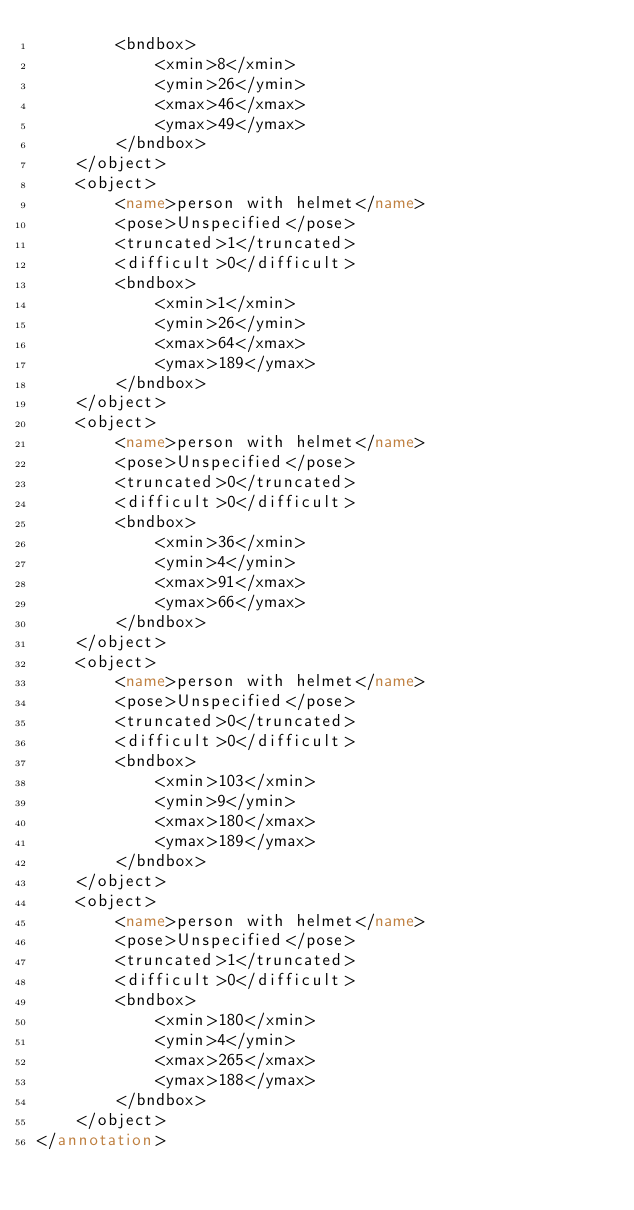Convert code to text. <code><loc_0><loc_0><loc_500><loc_500><_XML_>		<bndbox>
			<xmin>8</xmin>
			<ymin>26</ymin>
			<xmax>46</xmax>
			<ymax>49</ymax>
		</bndbox>
	</object>
	<object>
		<name>person with helmet</name>
		<pose>Unspecified</pose>
		<truncated>1</truncated>
		<difficult>0</difficult>
		<bndbox>
			<xmin>1</xmin>
			<ymin>26</ymin>
			<xmax>64</xmax>
			<ymax>189</ymax>
		</bndbox>
	</object>
	<object>
		<name>person with helmet</name>
		<pose>Unspecified</pose>
		<truncated>0</truncated>
		<difficult>0</difficult>
		<bndbox>
			<xmin>36</xmin>
			<ymin>4</ymin>
			<xmax>91</xmax>
			<ymax>66</ymax>
		</bndbox>
	</object>
	<object>
		<name>person with helmet</name>
		<pose>Unspecified</pose>
		<truncated>0</truncated>
		<difficult>0</difficult>
		<bndbox>
			<xmin>103</xmin>
			<ymin>9</ymin>
			<xmax>180</xmax>
			<ymax>189</ymax>
		</bndbox>
	</object>
	<object>
		<name>person with helmet</name>
		<pose>Unspecified</pose>
		<truncated>1</truncated>
		<difficult>0</difficult>
		<bndbox>
			<xmin>180</xmin>
			<ymin>4</ymin>
			<xmax>265</xmax>
			<ymax>188</ymax>
		</bndbox>
	</object>
</annotation>
</code> 